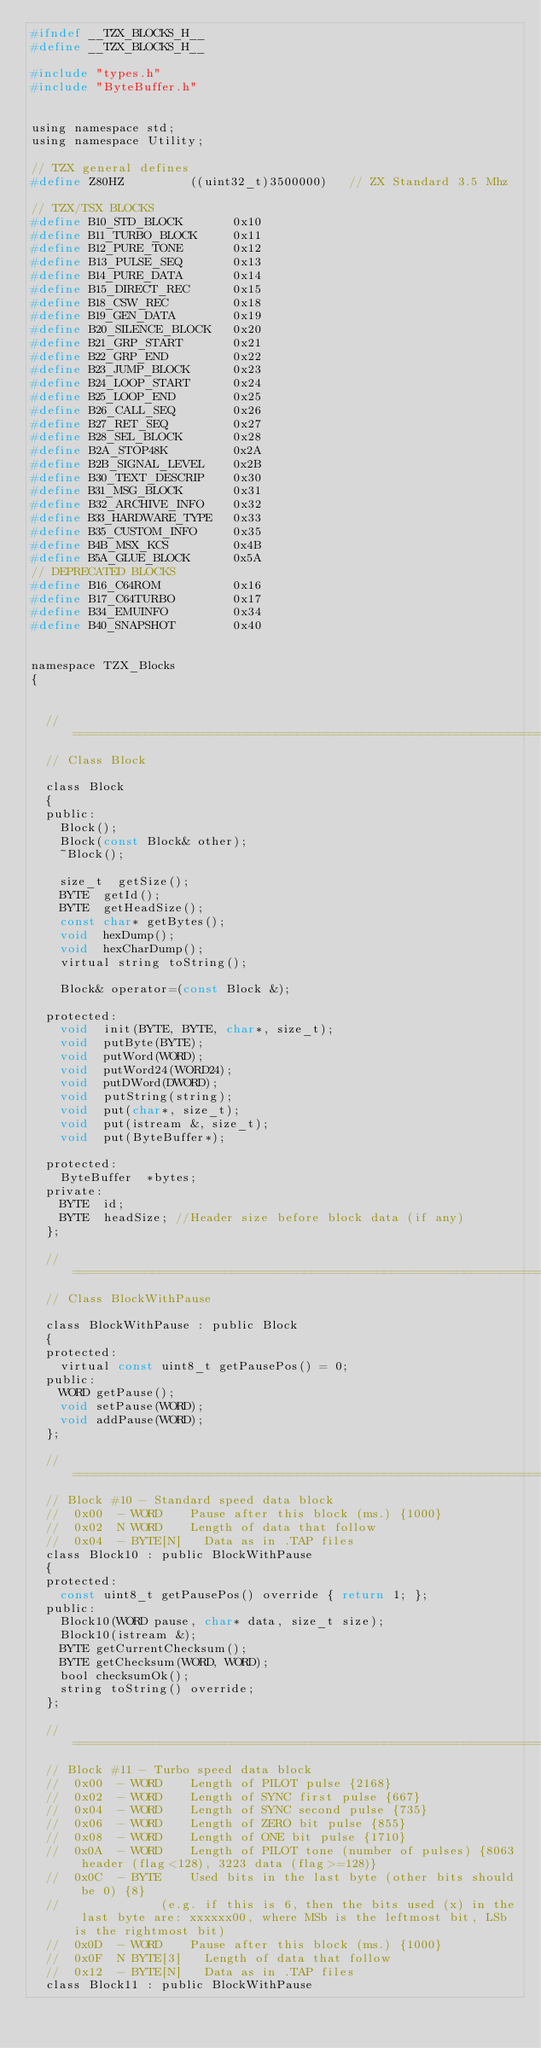<code> <loc_0><loc_0><loc_500><loc_500><_C_>#ifndef __TZX_BLOCKS_H__
#define __TZX_BLOCKS_H__

#include "types.h"
#include "ByteBuffer.h"


using namespace std;
using namespace Utility;

// TZX general defines
#define Z80HZ					((uint32_t)3500000)		// ZX Standard 3.5 Mhz

// TZX/TSX BLOCKS
#define B10_STD_BLOCK       0x10
#define B11_TURBO_BLOCK     0x11
#define B12_PURE_TONE       0x12
#define B13_PULSE_SEQ       0x13
#define B14_PURE_DATA       0x14
#define B15_DIRECT_REC      0x15
#define B18_CSW_REC         0x18
#define B19_GEN_DATA        0x19
#define B20_SILENCE_BLOCK   0x20
#define B21_GRP_START       0x21
#define B22_GRP_END         0x22
#define B23_JUMP_BLOCK      0x23
#define B24_LOOP_START      0x24
#define B25_LOOP_END        0x25
#define B26_CALL_SEQ        0x26
#define B27_RET_SEQ         0x27
#define B28_SEL_BLOCK       0x28
#define B2A_STOP48K         0x2A
#define B2B_SIGNAL_LEVEL    0x2B
#define B30_TEXT_DESCRIP    0x30
#define B31_MSG_BLOCK       0x31
#define B32_ARCHIVE_INFO    0x32
#define B33_HARDWARE_TYPE   0x33
#define B35_CUSTOM_INFO     0x35
#define B4B_MSX_KCS         0x4B
#define B5A_GLUE_BLOCK      0x5A
// DEPRECATED BLOCKS
#define B16_C64ROM          0x16
#define B17_C64TURBO        0x17
#define B34_EMUINFO         0x34
#define B40_SNAPSHOT        0x40


namespace TZX_Blocks
{
	

	// ============================================================================================
	// Class Block

	class Block
	{
	public:
		Block();
		Block(const Block& other);
		~Block();

		size_t	getSize();
		BYTE	getId();
		BYTE	getHeadSize();
		const char* getBytes();
		void	hexDump();
		void	hexCharDump();
		virtual string toString();
		
		Block& operator=(const Block &);

	protected:
		void	init(BYTE, BYTE, char*, size_t);
		void	putByte(BYTE);
		void	putWord(WORD);
		void	putWord24(WORD24);
		void	putDWord(DWORD);
		void	putString(string);
		void	put(char*, size_t);
		void	put(istream &, size_t);
		void	put(ByteBuffer*);

	protected:
		ByteBuffer	*bytes;
	private:
		BYTE	id;
		BYTE	headSize;	//Header size before block data (if any)
	};

	// ============================================================================================
	// Class BlockWithPause

	class BlockWithPause : public Block
	{
	protected:
		virtual const uint8_t getPausePos() = 0;
	public:
		WORD getPause();
		void setPause(WORD);
		void addPause(WORD);
	};

	// ============================================================================================
	// Block #10 - Standard speed data block
	//	0x00	-	WORD 		Pause after this block (ms.) {1000}
	//	0x02	N	WORD 		Length of data that follow
	//	0x04	-	BYTE[N]		Data as in .TAP files
	class Block10 : public BlockWithPause
	{
	protected:
		const uint8_t getPausePos() override { return 1; };
	public:
		Block10(WORD pause, char* data, size_t size);
		Block10(istream &);
		BYTE getCurrentChecksum();
		BYTE getChecksum(WORD, WORD);
		bool checksumOk();
		string toString() override;
	};

	// ============================================================================================
	// Block #11 - Turbo speed data block
	//	0x00	-	WORD		Length of PILOT pulse {2168}
	//	0x02	-	WORD		Length of SYNC first pulse {667}
	//	0x04	-	WORD		Length of SYNC second pulse {735}
	//	0x06	-	WORD		Length of ZERO bit pulse {855}
	//	0x08	-	WORD		Length of ONE bit pulse {1710}
	//	0x0A	-	WORD		Length of PILOT tone (number of pulses) {8063 header (flag<128), 3223 data (flag>=128)}
	//	0x0C	-	BYTE		Used bits in the last byte (other bits should be 0) {8}
	//							(e.g. if this is 6, then the bits used (x) in the last byte are: xxxxxx00, where MSb is the leftmost bit, LSb is the rightmost bit)
	//	0x0D	-	WORD		Pause after this block (ms.) {1000}
	//	0x0F	N	BYTE[3]		Length of data that follow
	//	0x12	-	BYTE[N]		Data as in .TAP files
	class Block11 : public BlockWithPause</code> 